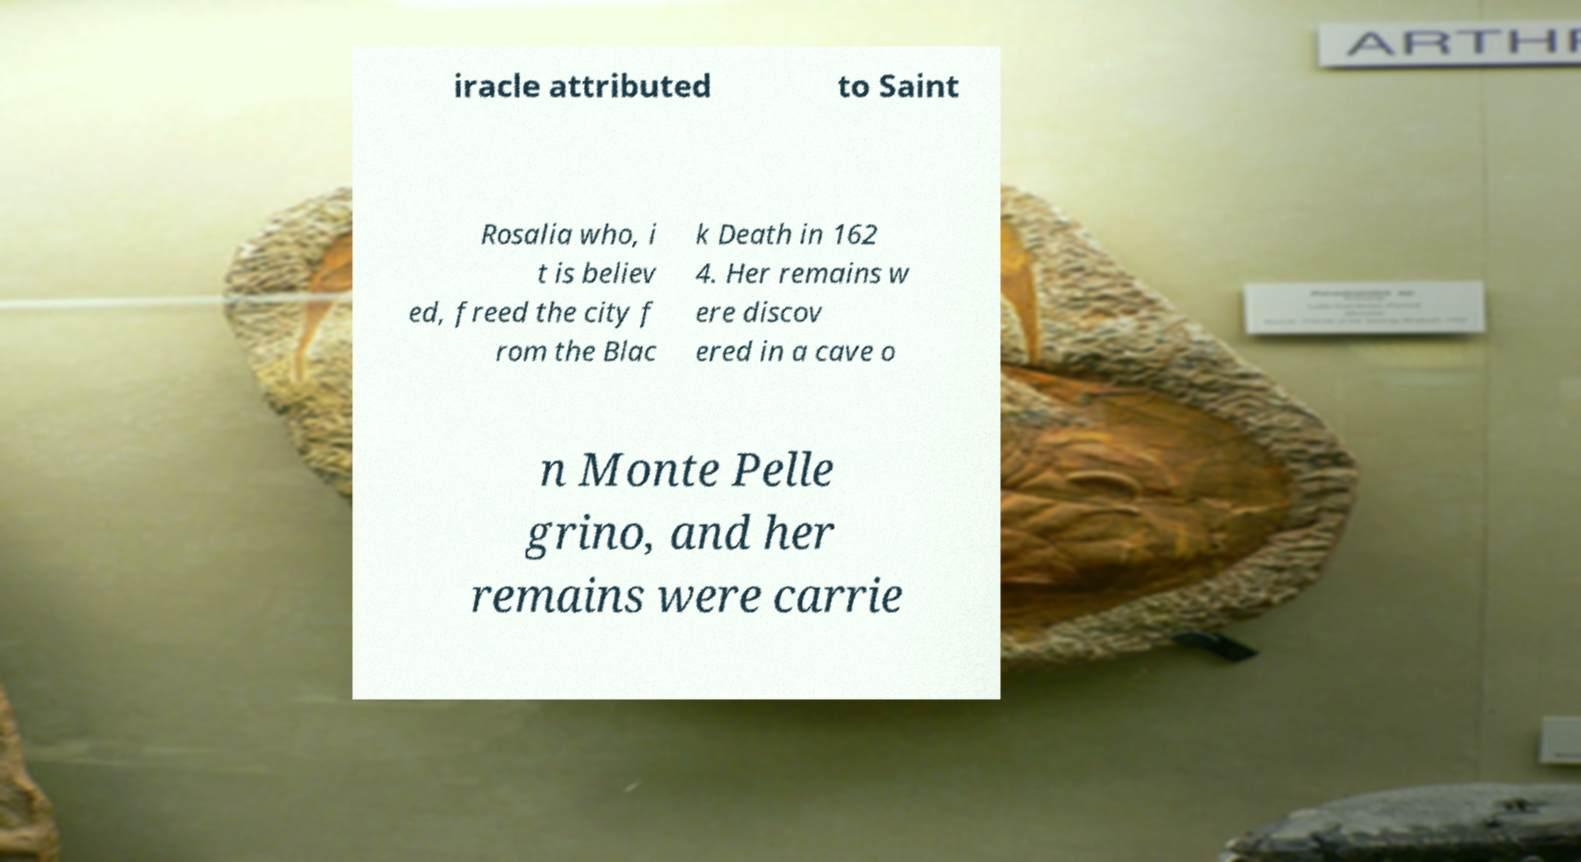Can you accurately transcribe the text from the provided image for me? iracle attributed to Saint Rosalia who, i t is believ ed, freed the city f rom the Blac k Death in 162 4. Her remains w ere discov ered in a cave o n Monte Pelle grino, and her remains were carrie 